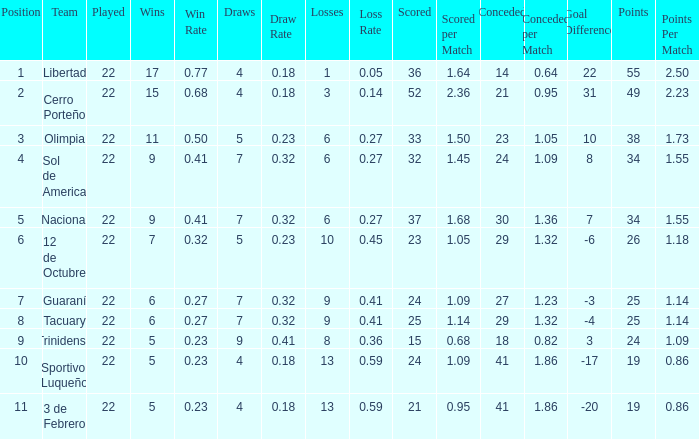What was the number of losses when the scored value was 25? 9.0. 